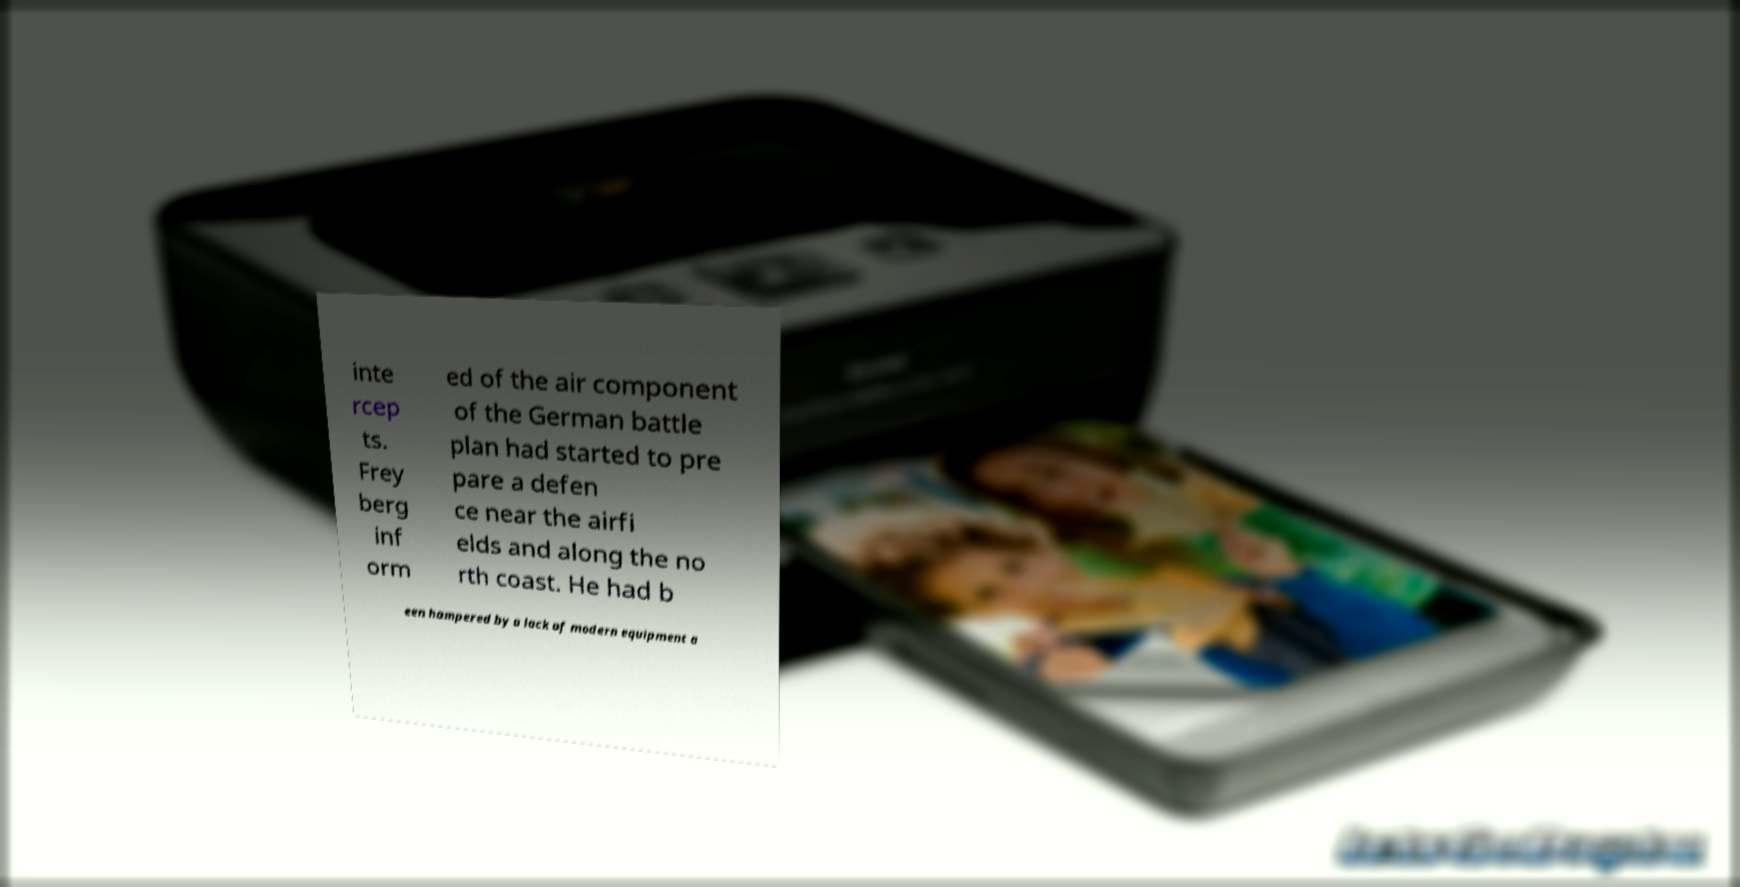Can you accurately transcribe the text from the provided image for me? inte rcep ts. Frey berg inf orm ed of the air component of the German battle plan had started to pre pare a defen ce near the airfi elds and along the no rth coast. He had b een hampered by a lack of modern equipment a 